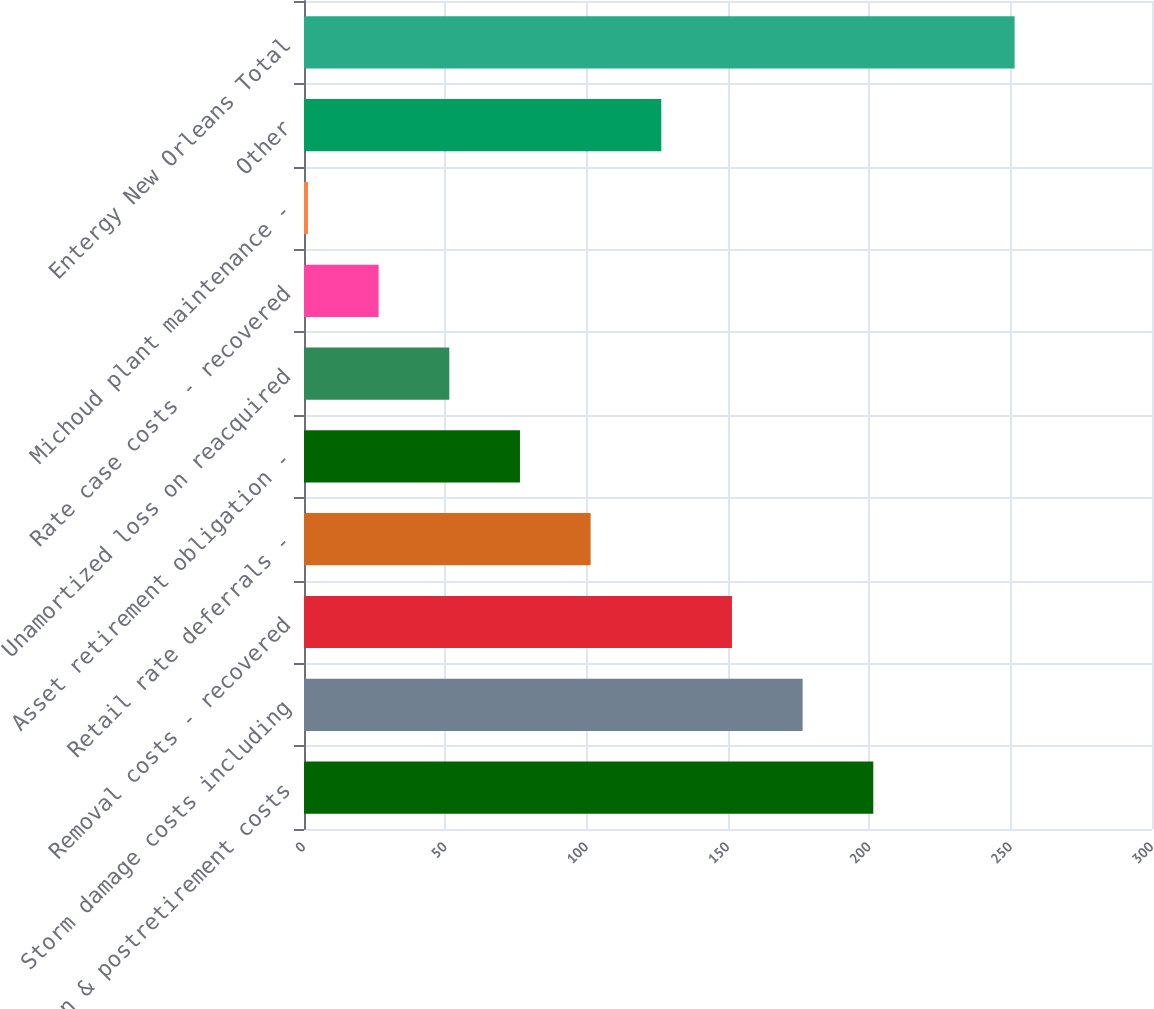Convert chart. <chart><loc_0><loc_0><loc_500><loc_500><bar_chart><fcel>Pension & postretirement costs<fcel>Storm damage costs including<fcel>Removal costs - recovered<fcel>Retail rate deferrals -<fcel>Asset retirement obligation -<fcel>Unamortized loss on reacquired<fcel>Rate case costs - recovered<fcel>Michoud plant maintenance -<fcel>Other<fcel>Entergy New Orleans Total<nl><fcel>201.4<fcel>176.4<fcel>151.4<fcel>101.4<fcel>76.4<fcel>51.4<fcel>26.4<fcel>1.4<fcel>126.4<fcel>251.4<nl></chart> 